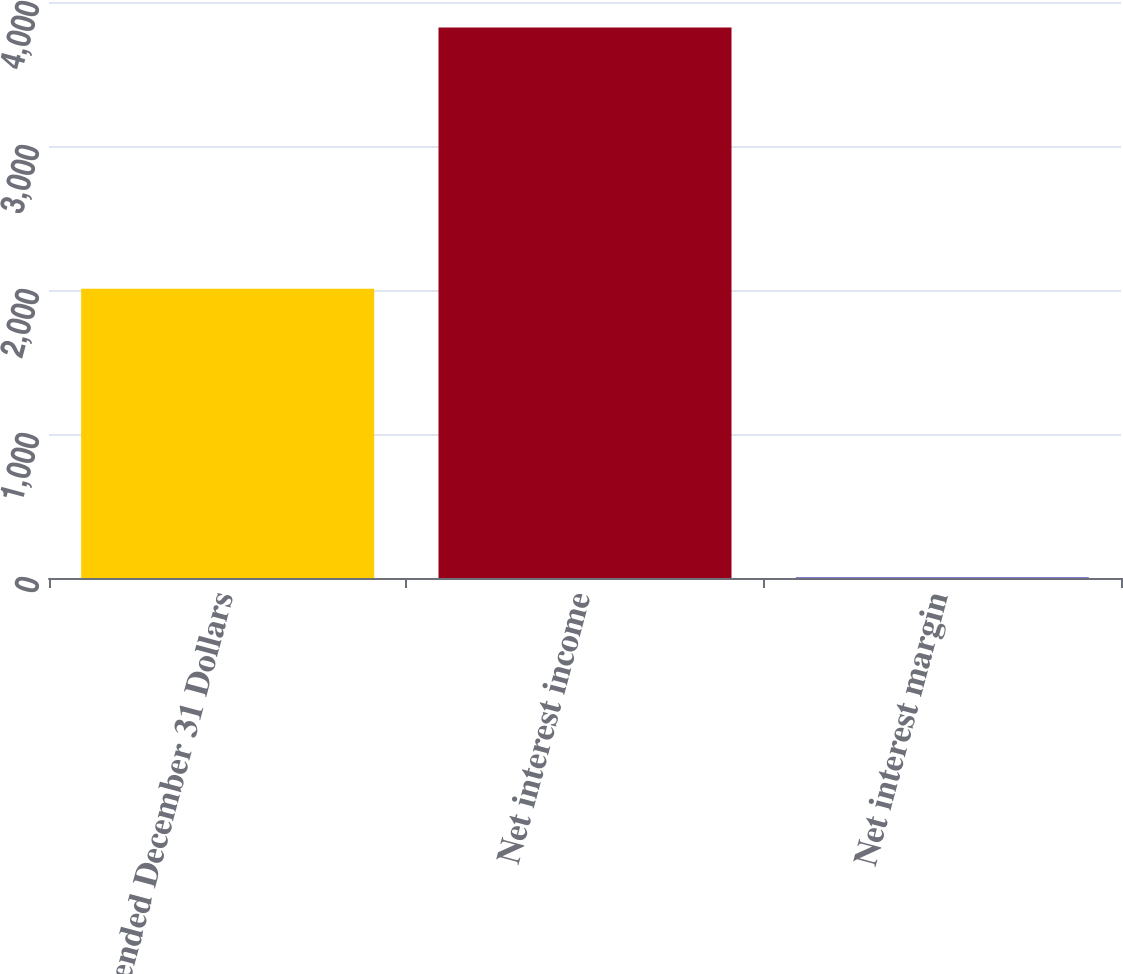Convert chart to OTSL. <chart><loc_0><loc_0><loc_500><loc_500><bar_chart><fcel>Year ended December 31 Dollars<fcel>Net interest income<fcel>Net interest margin<nl><fcel>2008<fcel>3823<fcel>3.37<nl></chart> 